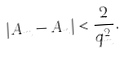Convert formula to latex. <formula><loc_0><loc_0><loc_500><loc_500>| A _ { m } - A _ { n } | < \frac { 2 } { q _ { m } ^ { 2 } } .</formula> 